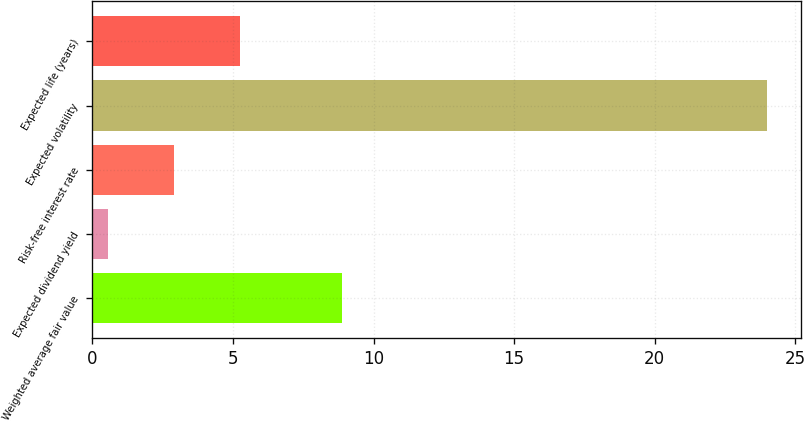<chart> <loc_0><loc_0><loc_500><loc_500><bar_chart><fcel>Weighted average fair value<fcel>Expected dividend yield<fcel>Risk-free interest rate<fcel>Expected volatility<fcel>Expected life (years)<nl><fcel>8.86<fcel>0.55<fcel>2.9<fcel>24<fcel>5.25<nl></chart> 